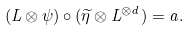<formula> <loc_0><loc_0><loc_500><loc_500>( L \otimes \psi ) \circ ( \widetilde { \eta } \otimes L ^ { \otimes d } ) = a .</formula> 